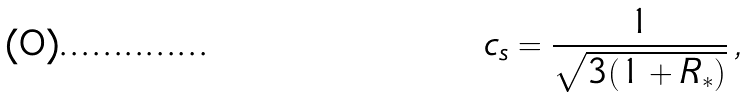<formula> <loc_0><loc_0><loc_500><loc_500>c _ { s } = \frac { 1 } { \sqrt { 3 ( 1 + R _ { * } ) } } \, ,</formula> 